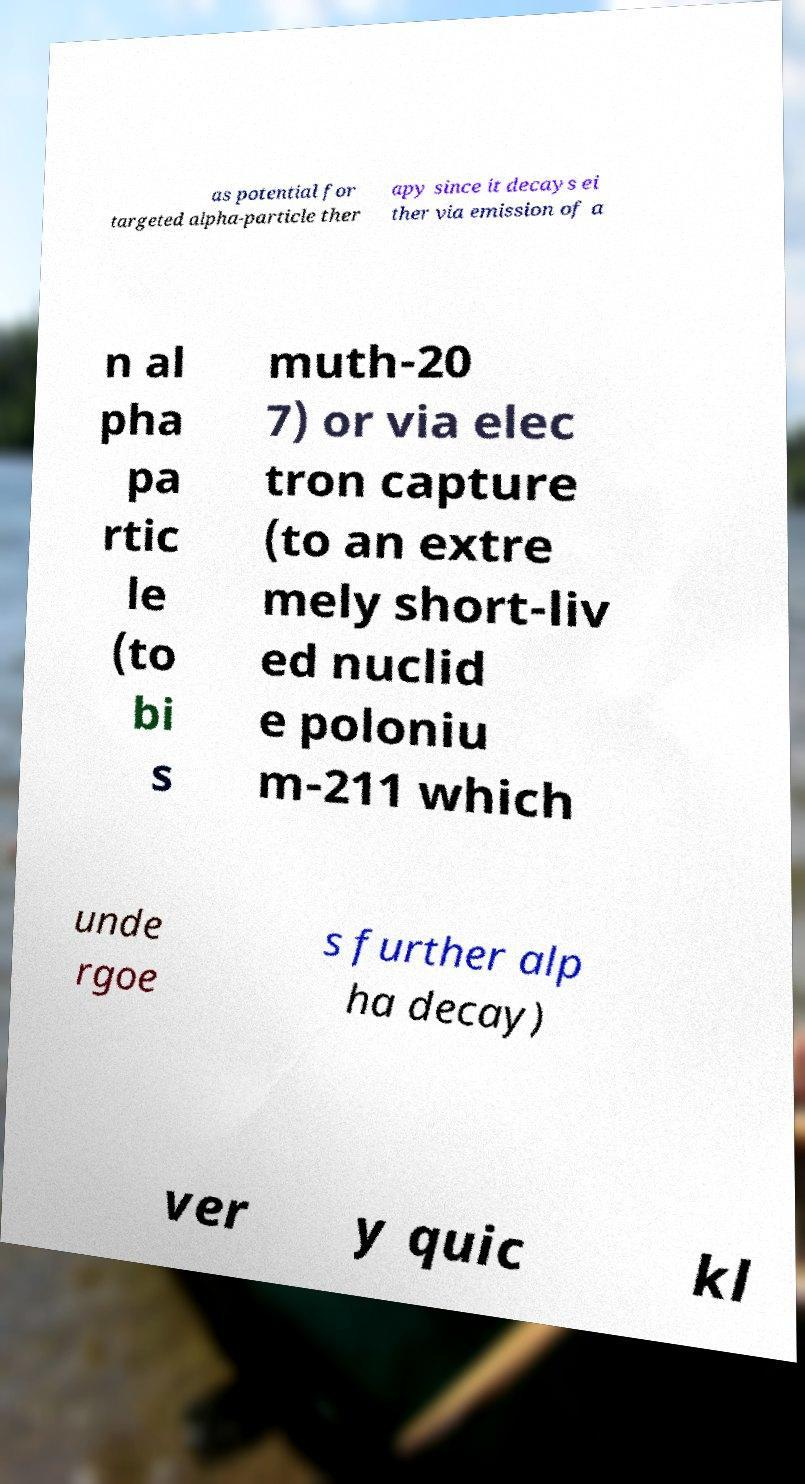I need the written content from this picture converted into text. Can you do that? as potential for targeted alpha-particle ther apy since it decays ei ther via emission of a n al pha pa rtic le (to bi s muth-20 7) or via elec tron capture (to an extre mely short-liv ed nuclid e poloniu m-211 which unde rgoe s further alp ha decay) ver y quic kl 